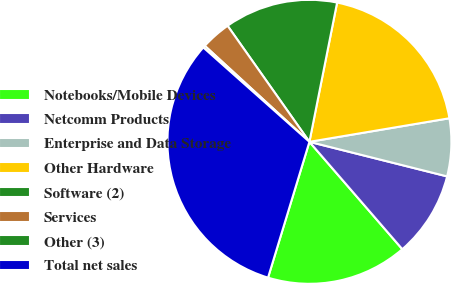Convert chart. <chart><loc_0><loc_0><loc_500><loc_500><pie_chart><fcel>Notebooks/Mobile Devices<fcel>Netcomm Products<fcel>Enterprise and Data Storage<fcel>Other Hardware<fcel>Software (2)<fcel>Services<fcel>Other (3)<fcel>Total net sales<nl><fcel>16.06%<fcel>9.73%<fcel>6.57%<fcel>19.22%<fcel>12.9%<fcel>3.41%<fcel>0.25%<fcel>31.86%<nl></chart> 